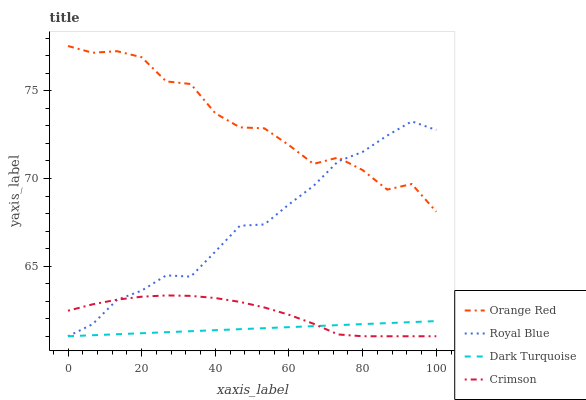Does Dark Turquoise have the minimum area under the curve?
Answer yes or no. Yes. Does Orange Red have the maximum area under the curve?
Answer yes or no. Yes. Does Royal Blue have the minimum area under the curve?
Answer yes or no. No. Does Royal Blue have the maximum area under the curve?
Answer yes or no. No. Is Dark Turquoise the smoothest?
Answer yes or no. Yes. Is Orange Red the roughest?
Answer yes or no. Yes. Is Royal Blue the smoothest?
Answer yes or no. No. Is Royal Blue the roughest?
Answer yes or no. No. Does Crimson have the lowest value?
Answer yes or no. Yes. Does Orange Red have the lowest value?
Answer yes or no. No. Does Orange Red have the highest value?
Answer yes or no. Yes. Does Royal Blue have the highest value?
Answer yes or no. No. Is Crimson less than Orange Red?
Answer yes or no. Yes. Is Orange Red greater than Crimson?
Answer yes or no. Yes. Does Crimson intersect Dark Turquoise?
Answer yes or no. Yes. Is Crimson less than Dark Turquoise?
Answer yes or no. No. Is Crimson greater than Dark Turquoise?
Answer yes or no. No. Does Crimson intersect Orange Red?
Answer yes or no. No. 